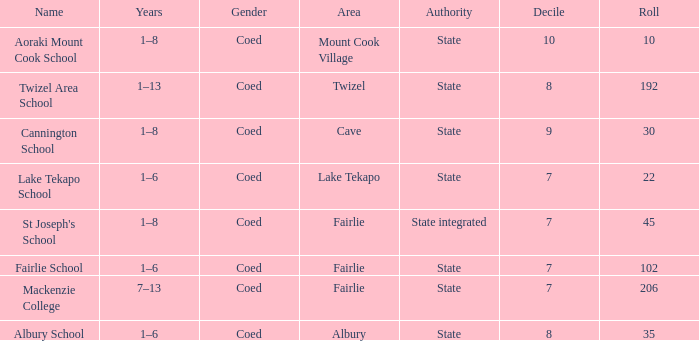What is the total Decile that has a state authority, fairlie area and roll smarter than 206? 1.0. 